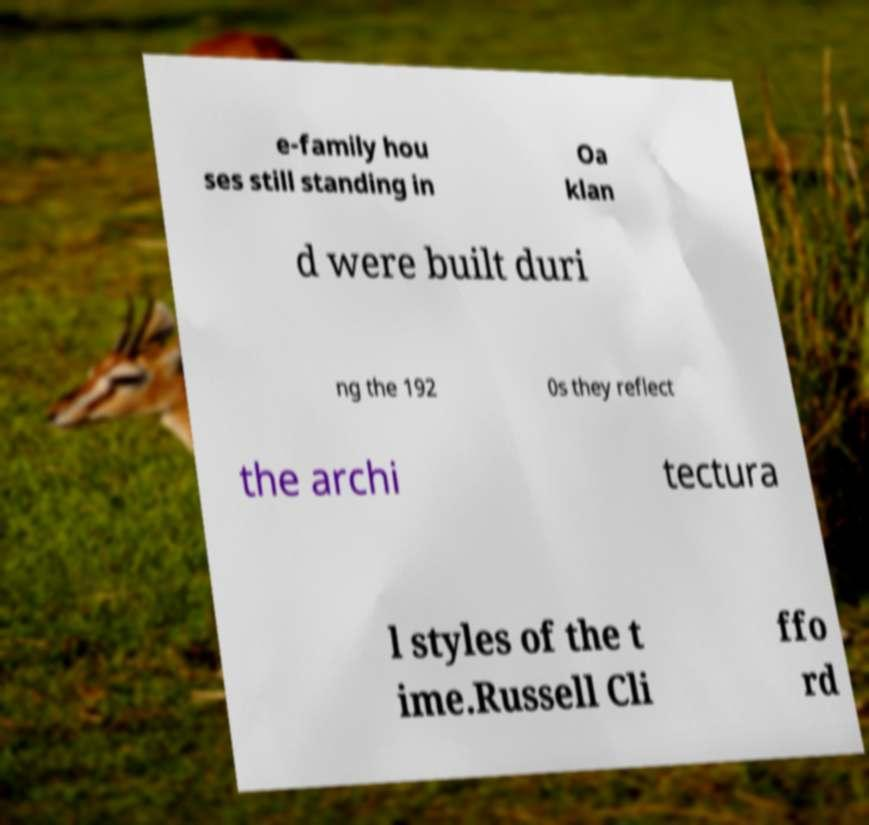Please read and relay the text visible in this image. What does it say? e-family hou ses still standing in Oa klan d were built duri ng the 192 0s they reflect the archi tectura l styles of the t ime.Russell Cli ffo rd 